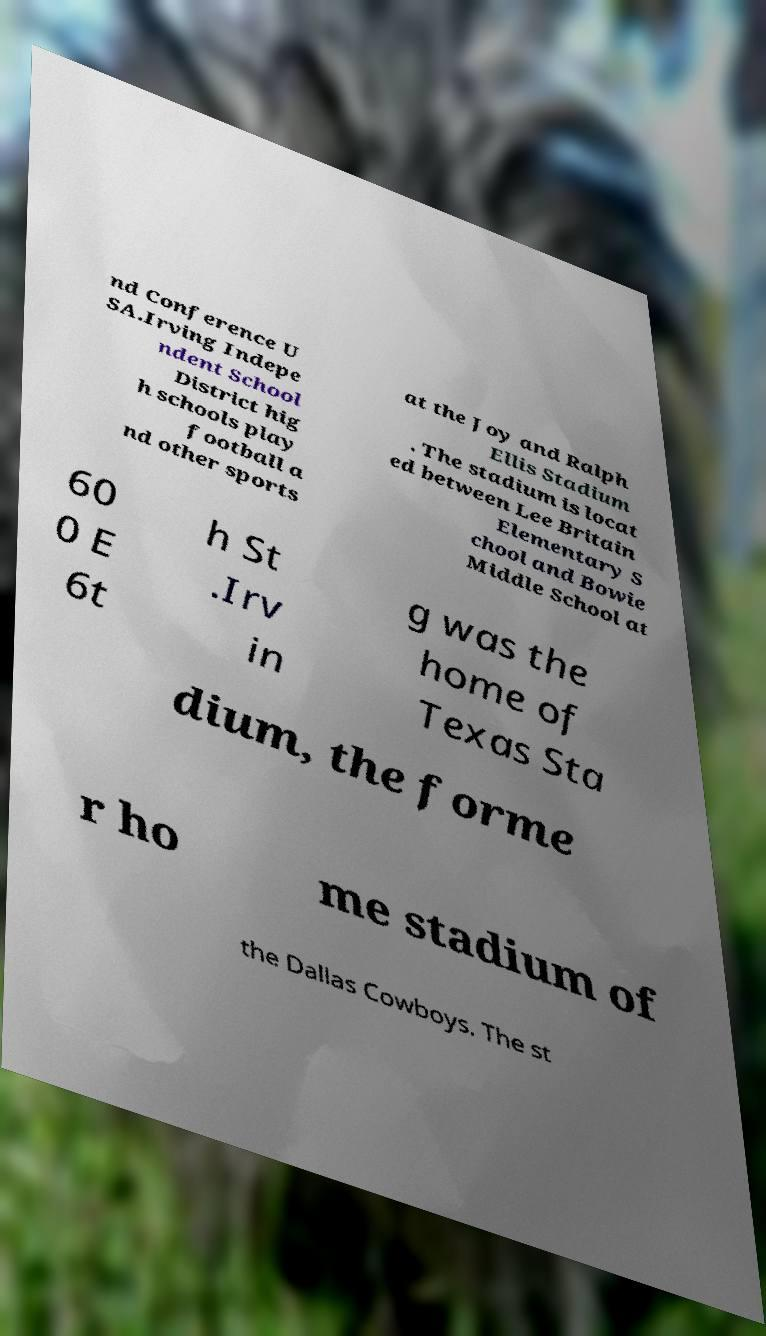Could you assist in decoding the text presented in this image and type it out clearly? nd Conference U SA.Irving Indepe ndent School District hig h schools play football a nd other sports at the Joy and Ralph Ellis Stadium . The stadium is locat ed between Lee Britain Elementary S chool and Bowie Middle School at 60 0 E 6t h St .Irv in g was the home of Texas Sta dium, the forme r ho me stadium of the Dallas Cowboys. The st 